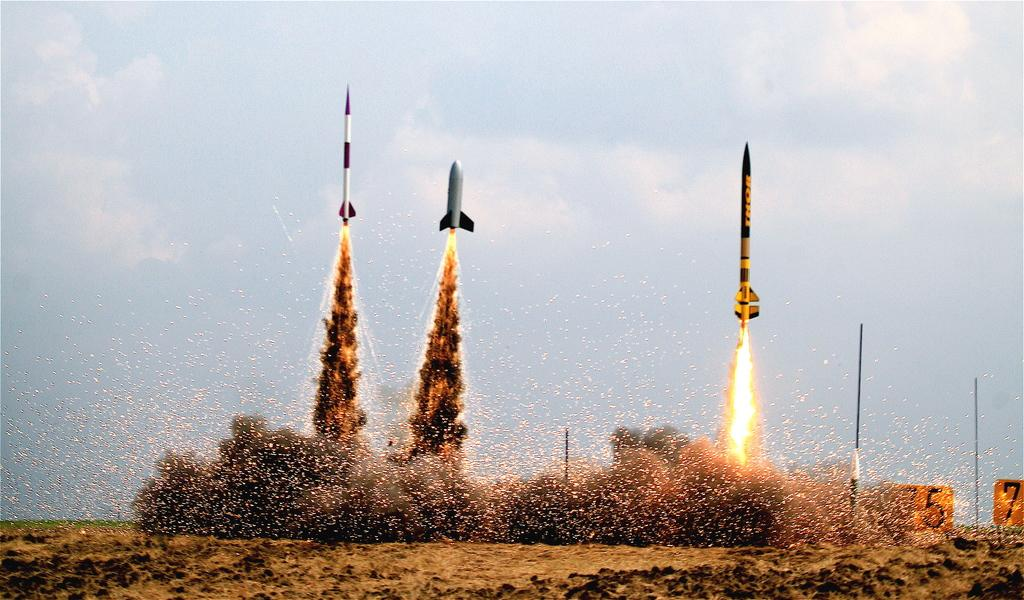What is the main subject of the image? The main subject of the image is three rockets. What is happening to the rockets in the image? The rockets are emitting smoke and fire. What can be seen in the sky in the image? The sky is visible at the top of the image. What else is present in the middle of the image besides the rockets? There are poles visible in the middle of the image. What type of twig is being used to control the rockets in the image? There is no twig present in the image, and the rockets are not being controlled by any object. 